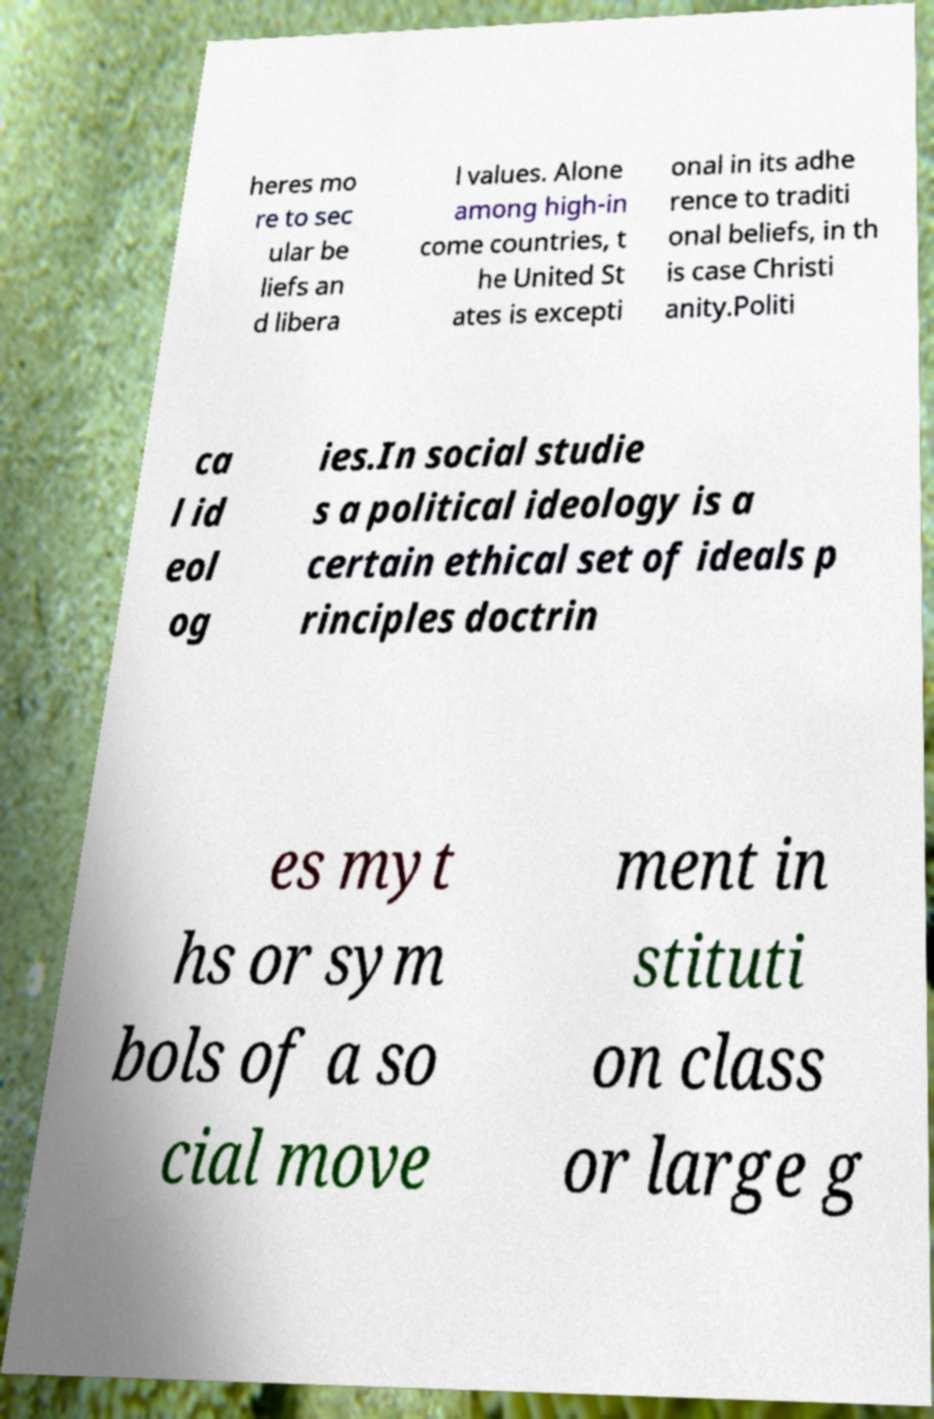Please read and relay the text visible in this image. What does it say? heres mo re to sec ular be liefs an d libera l values. Alone among high-in come countries, t he United St ates is excepti onal in its adhe rence to traditi onal beliefs, in th is case Christi anity.Politi ca l id eol og ies.In social studie s a political ideology is a certain ethical set of ideals p rinciples doctrin es myt hs or sym bols of a so cial move ment in stituti on class or large g 